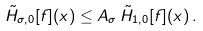Convert formula to latex. <formula><loc_0><loc_0><loc_500><loc_500>\tilde { H } _ { \sigma , 0 } [ f ] ( x ) \leq A _ { \sigma } \, \tilde { H } _ { 1 , 0 } [ f ] ( x ) \, .</formula> 